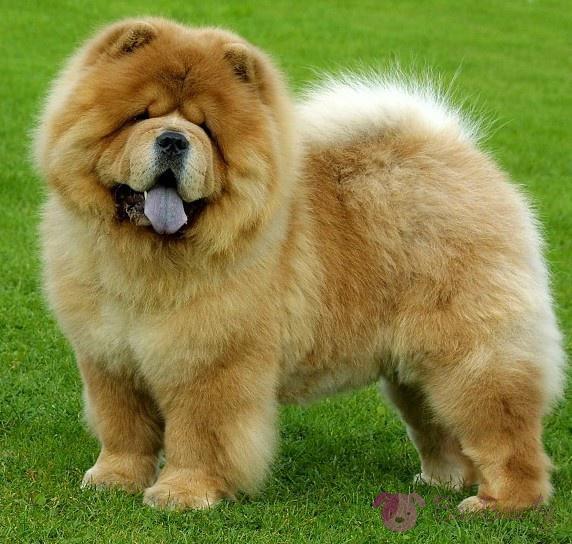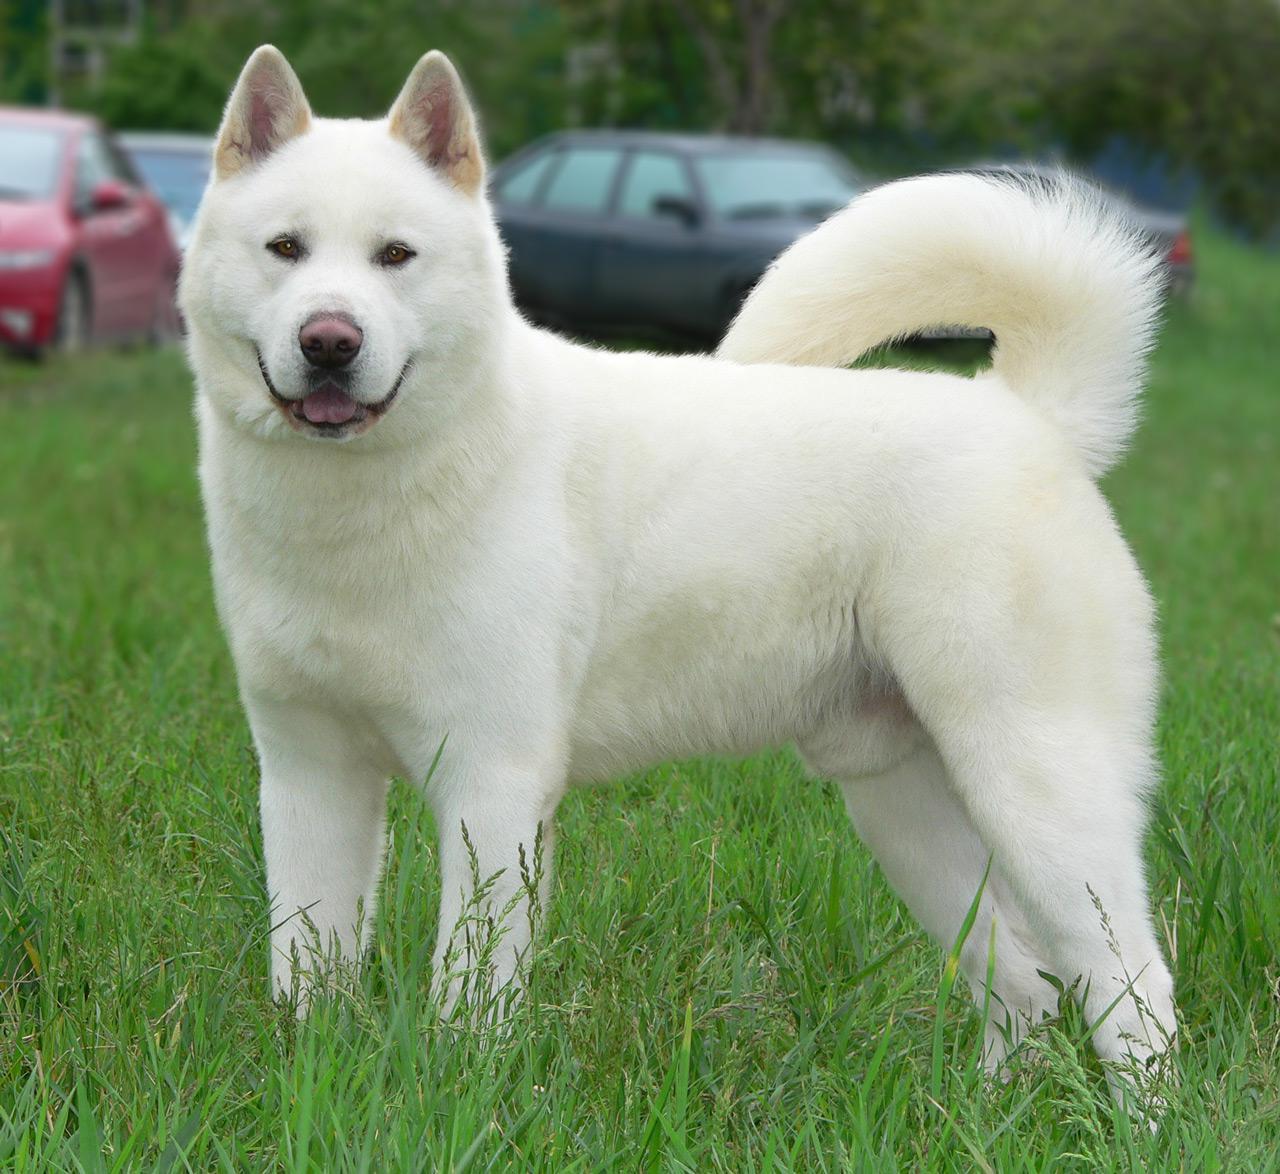The first image is the image on the left, the second image is the image on the right. Evaluate the accuracy of this statement regarding the images: "a brick wall is behind a dog.". Is it true? Answer yes or no. No. 